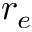<formula> <loc_0><loc_0><loc_500><loc_500>r _ { e }</formula> 